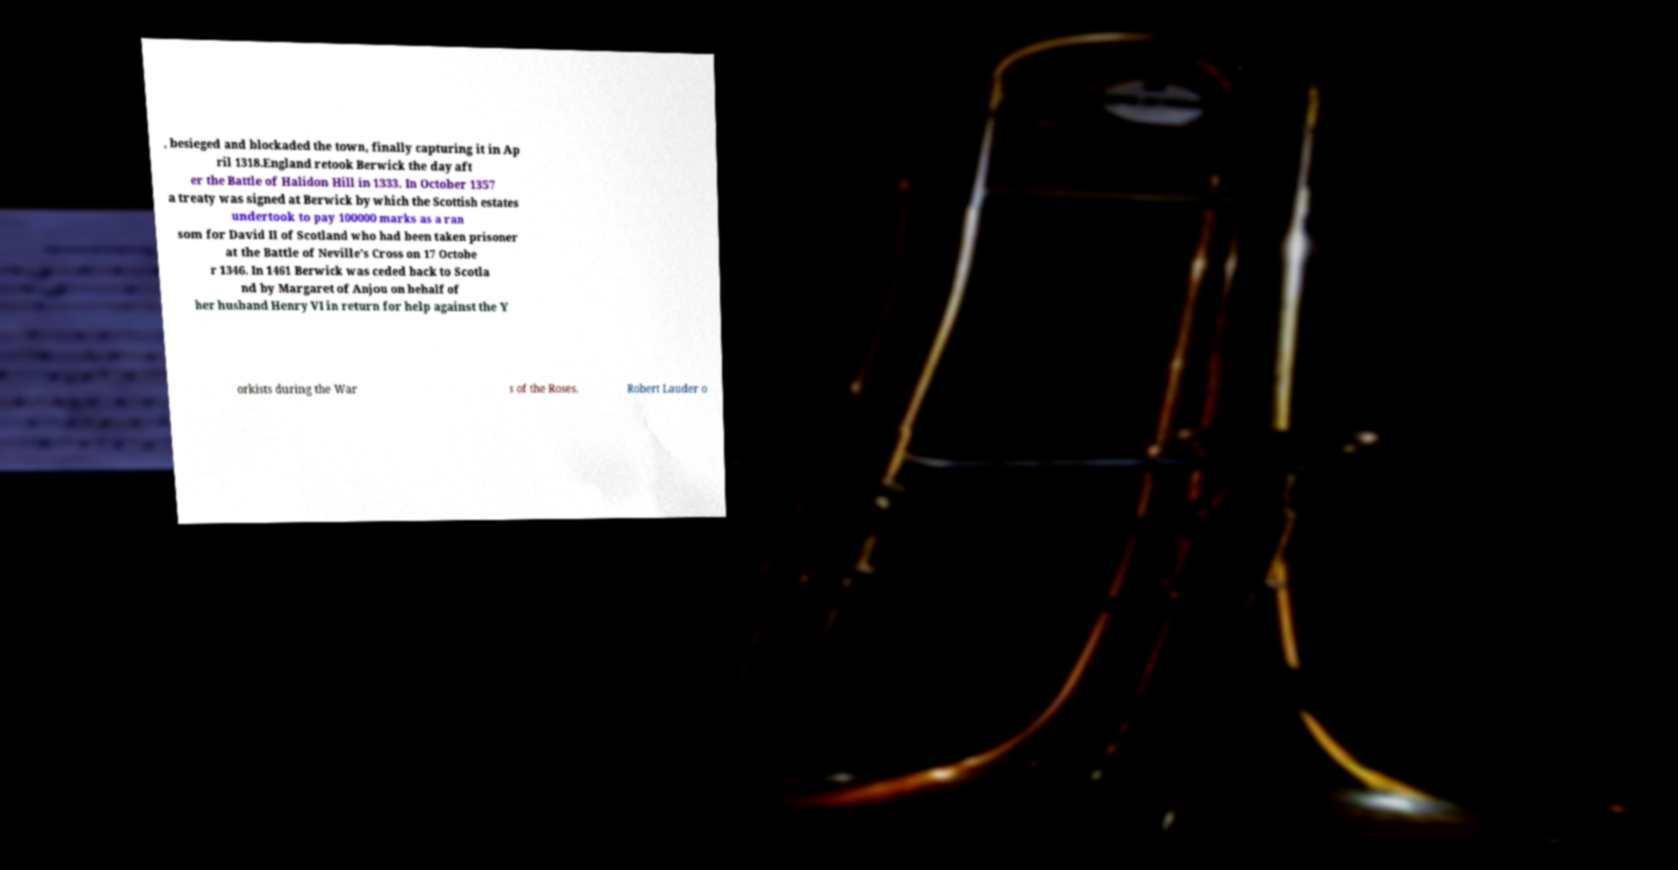For documentation purposes, I need the text within this image transcribed. Could you provide that? , besieged and blockaded the town, finally capturing it in Ap ril 1318.England retook Berwick the day aft er the Battle of Halidon Hill in 1333. In October 1357 a treaty was signed at Berwick by which the Scottish estates undertook to pay 100000 marks as a ran som for David II of Scotland who had been taken prisoner at the Battle of Neville's Cross on 17 Octobe r 1346. In 1461 Berwick was ceded back to Scotla nd by Margaret of Anjou on behalf of her husband Henry VI in return for help against the Y orkists during the War s of the Roses. Robert Lauder o 